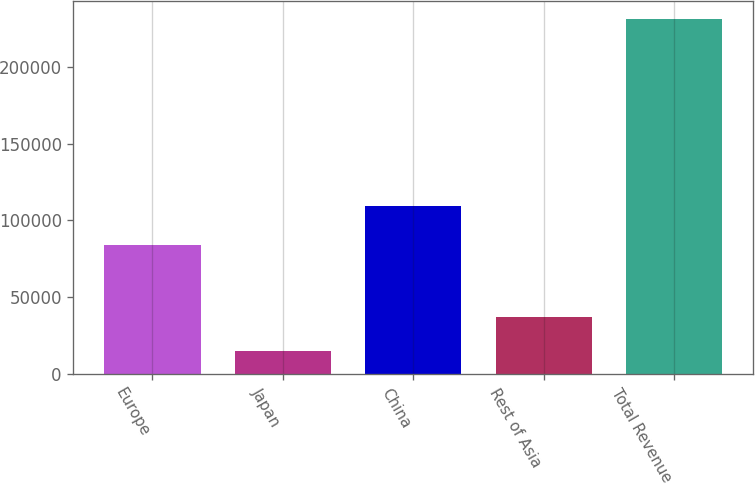<chart> <loc_0><loc_0><loc_500><loc_500><bar_chart><fcel>Europe<fcel>Japan<fcel>China<fcel>Rest of Asia<fcel>Total Revenue<nl><fcel>83892<fcel>15250<fcel>109685<fcel>36833.4<fcel>231084<nl></chart> 